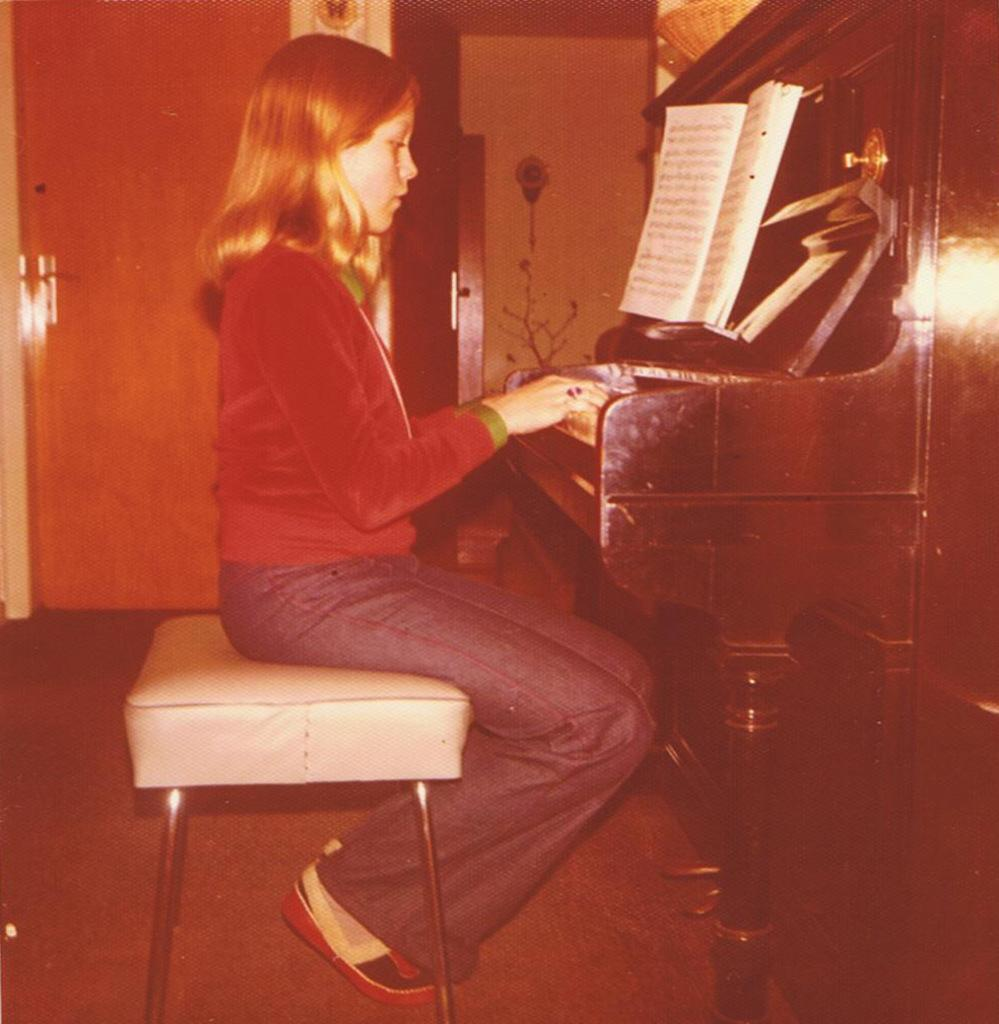What is the person in the image doing? The person is sitting on a stool and playing the keyboard. What else can be seen in the image besides the person and the keyboard? There is a book, a wall, a door, the floor, and a basket visible in the image. Can you describe the location of the door in the image? The door is located on the wall in the image. What might the person be using to hold or store items in the image? The basket in the image could be used for holding or storing items. How many centimeters tall is the daughter in the image? There is no daughter present in the image, and the person's height is not mentioned in the provided facts. What type of yarn is being used to knit a scarf in the image? There is no yarn or knitting activity present in the image. 